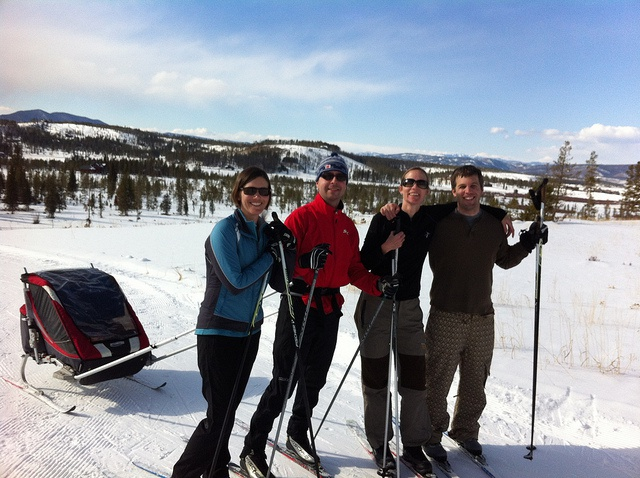Describe the objects in this image and their specific colors. I can see people in darkgray, black, darkblue, gray, and lightgray tones, people in darkgray, black, maroon, gray, and brown tones, people in darkgray, black, gray, and maroon tones, people in darkgray, black, gray, and maroon tones, and skis in darkgray, black, gray, and lightgray tones in this image. 